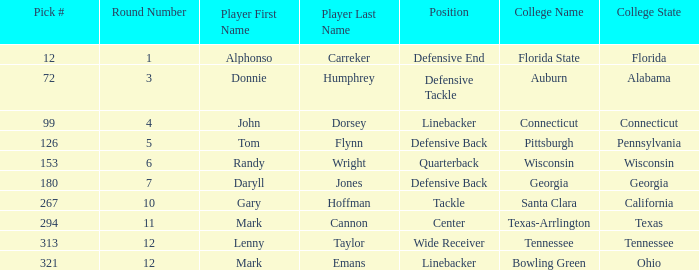What Player is a Wide Receiver? Lenny Taylor. 